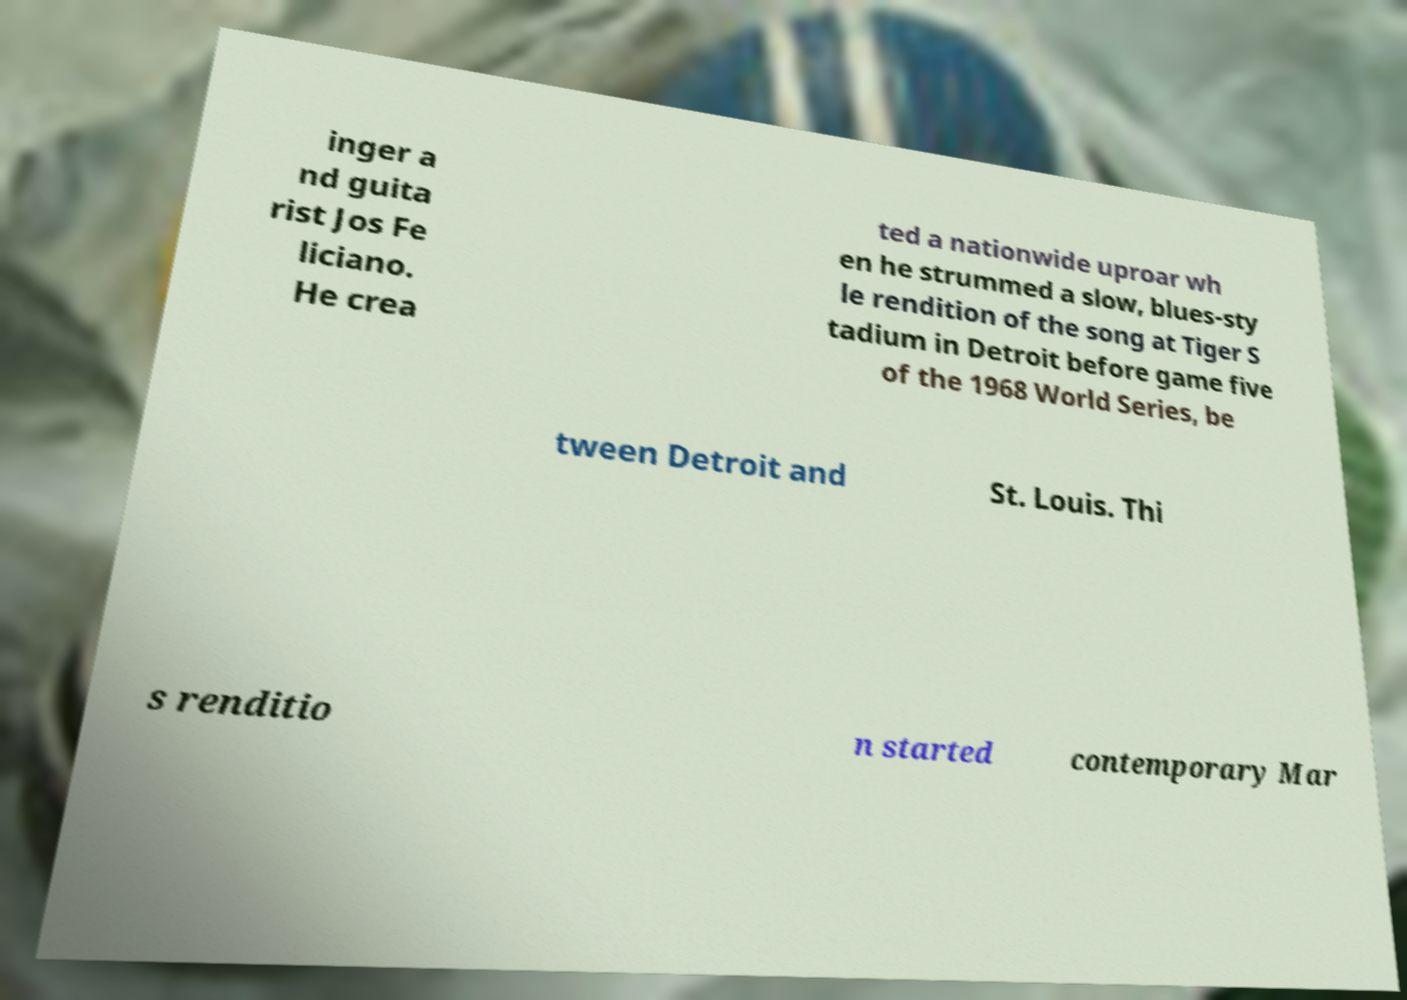Please read and relay the text visible in this image. What does it say? inger a nd guita rist Jos Fe liciano. He crea ted a nationwide uproar wh en he strummed a slow, blues-sty le rendition of the song at Tiger S tadium in Detroit before game five of the 1968 World Series, be tween Detroit and St. Louis. Thi s renditio n started contemporary Mar 